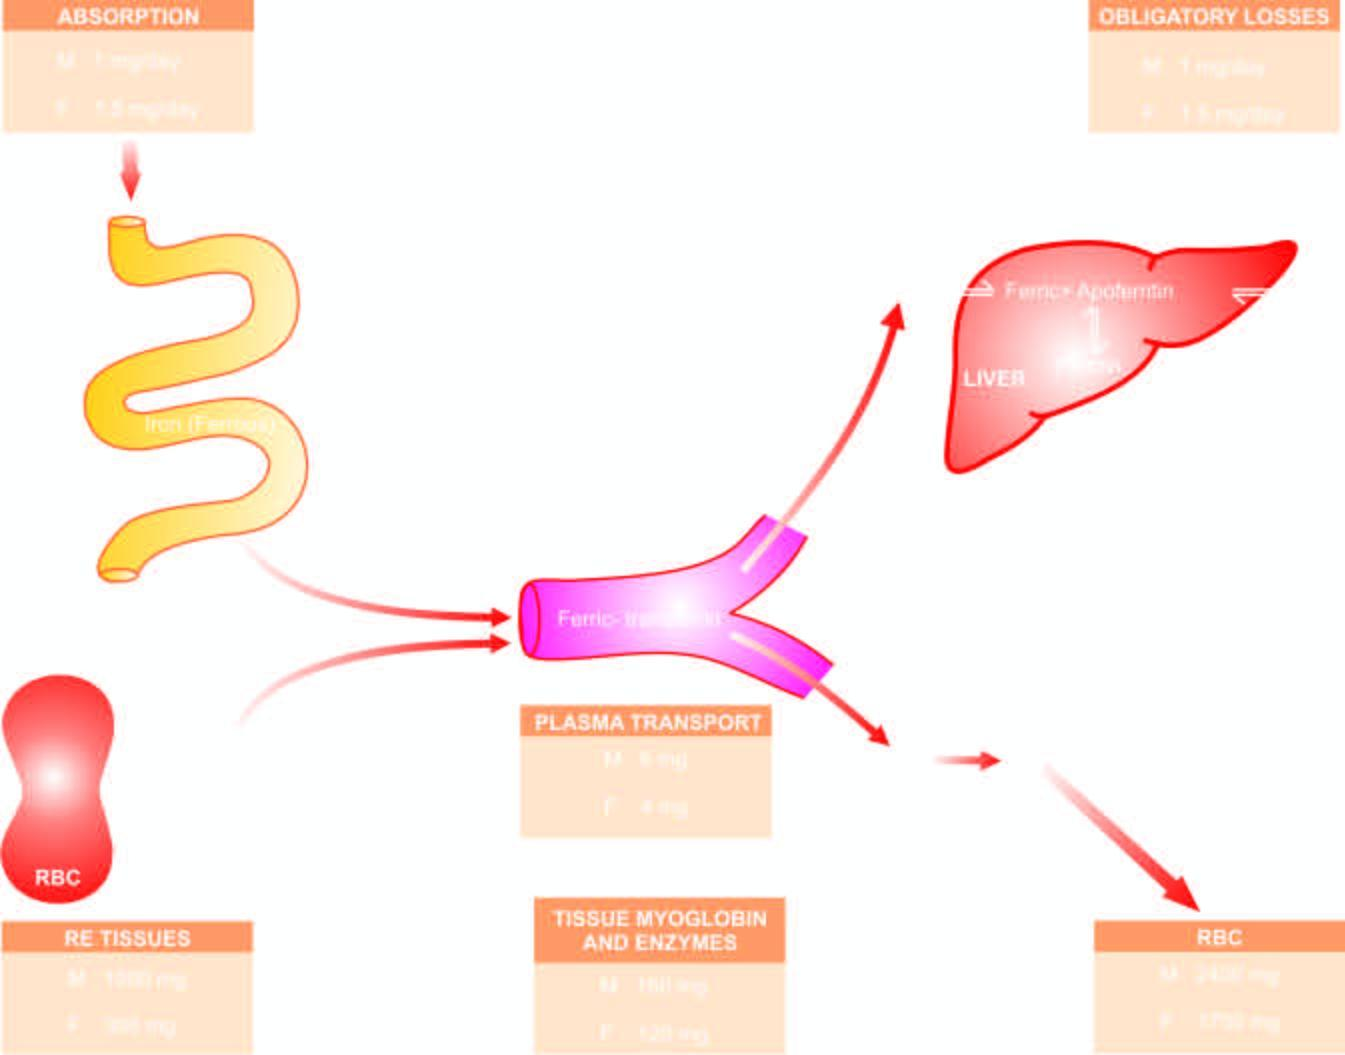when are the mature red cells released?
Answer the question using a single word or phrase. On completion of their lifespan of 120 days 